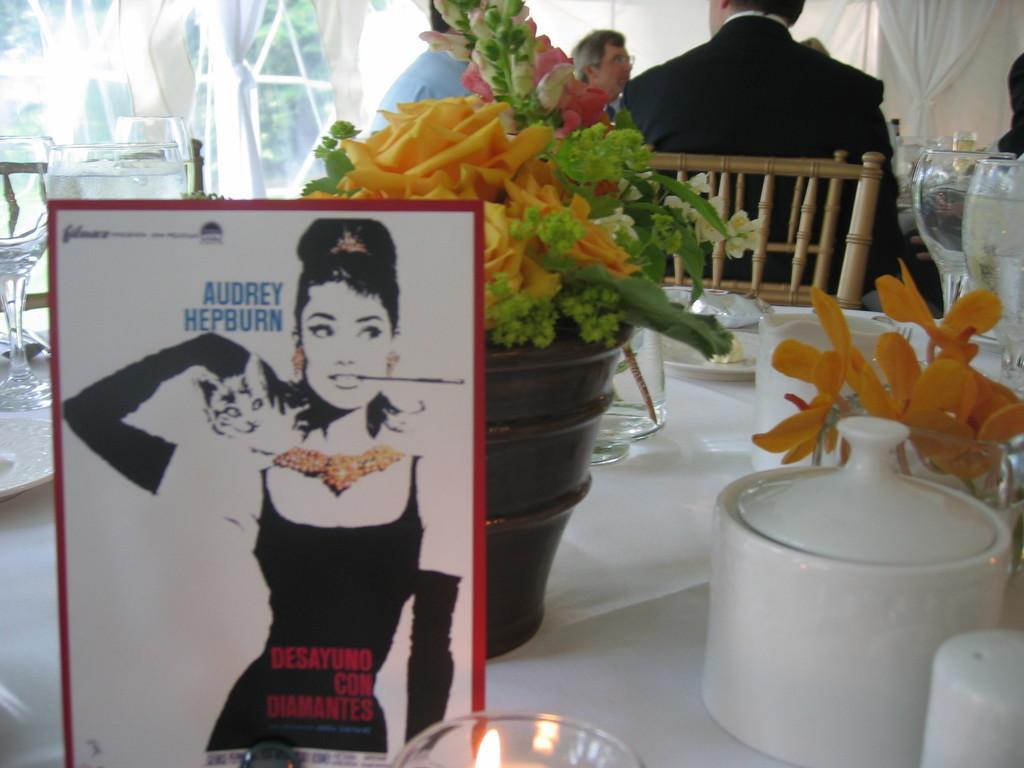Could you give a brief overview of what you see in this image? In this picture we can see a view of the dining table with flower pot, water glasses and white cups. In front bottom side we can see a brochure of a girl. Behind we can see some people sitting on the chairs and glass window. 